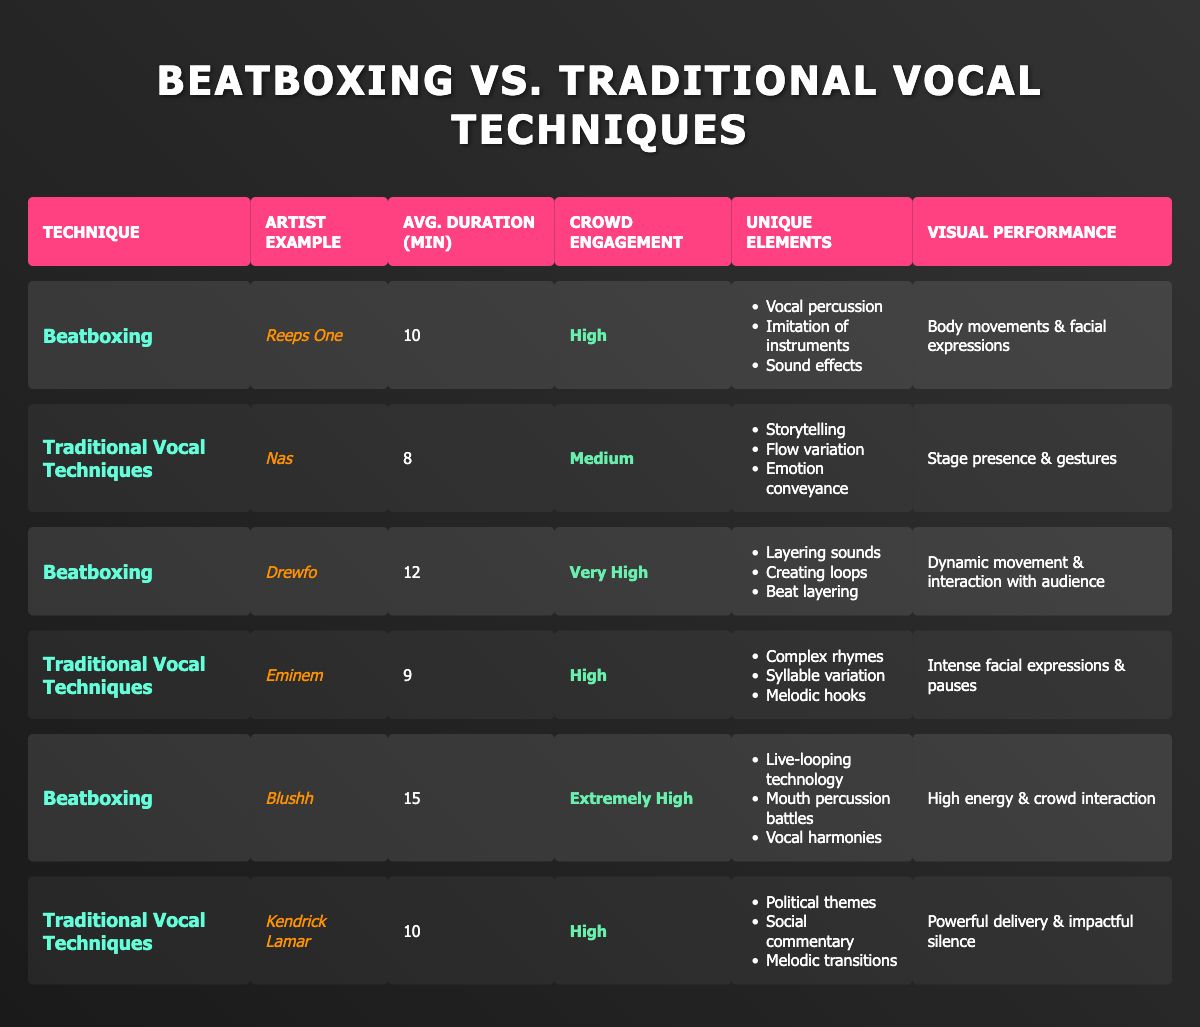What is the average performance duration for beatboxing artists? The performances for beatboxing from the table are: 10, 12, and 15 minutes. Average duration = (10 + 12 + 15) / 3 = 37 / 3 = 12.33 minutes.
Answer: 12.33 minutes Which artist is associated with traditional vocal techniques having a high crowd engagement level? From the table, Eminem and Kendrick Lamar both have a high crowd engagement level, but since Kendrick Lamar is said to have a powerful delivery which aligns with the high engagement, he is the most notable example.
Answer: Kendrick Lamar How many unique elements are listed for Drewfo's beatboxing performance? The table specifies 3 unique elements for Drewfo: Layering sounds, Creating loops, and Beat layering.
Answer: 3 Is Blushh's crowd engagement level higher than that of Nas? Blushh has an extremely high engagement level, while Nas has a medium level. Since extremely high is greater than medium, the statement is true.
Answer: Yes Compare the average performance duration of beatboxing and traditional vocal techniques. Beatboxing average duration is 12.33 minutes, while traditional vocal techniques average is (8 + 9 + 10) / 3 = 27 / 3 = 9 minutes. Since 12.33 is greater than 9, beatboxing has a longer average performance duration.
Answer: Beatboxing is longer Which technique has the highest crowd engagement level overall? Reviewing the table, Blushh has the highest crowd engagement level listed as "Extremely High", while no other techniques exceed "Very High".
Answer: Beatboxing List the unique elements used by Reeps One in his beatbox performance. The table shows Reeps One's unique elements as: Vocal percussion, Imitation of instruments, and Sound effects.
Answer: Vocal percussion, Imitation of instruments, Sound effects What is the total number of minutes for all beatboxing performances listed? The total duration for the beatboxing performances is 10 + 12 + 15 = 37 minutes.
Answer: 37 minutes Is there an artist example in traditional vocal techniques that engages the crowd at a medium level? The table indicates that Nas has a crowd engagement level classified as medium.
Answer: Yes Which artist is known for political themes among those using traditional vocal techniques? Looking at the table, Kendrick Lamar is the only traditional vocal artist mentioned with unique elements related to political themes.
Answer: Kendrick Lamar 